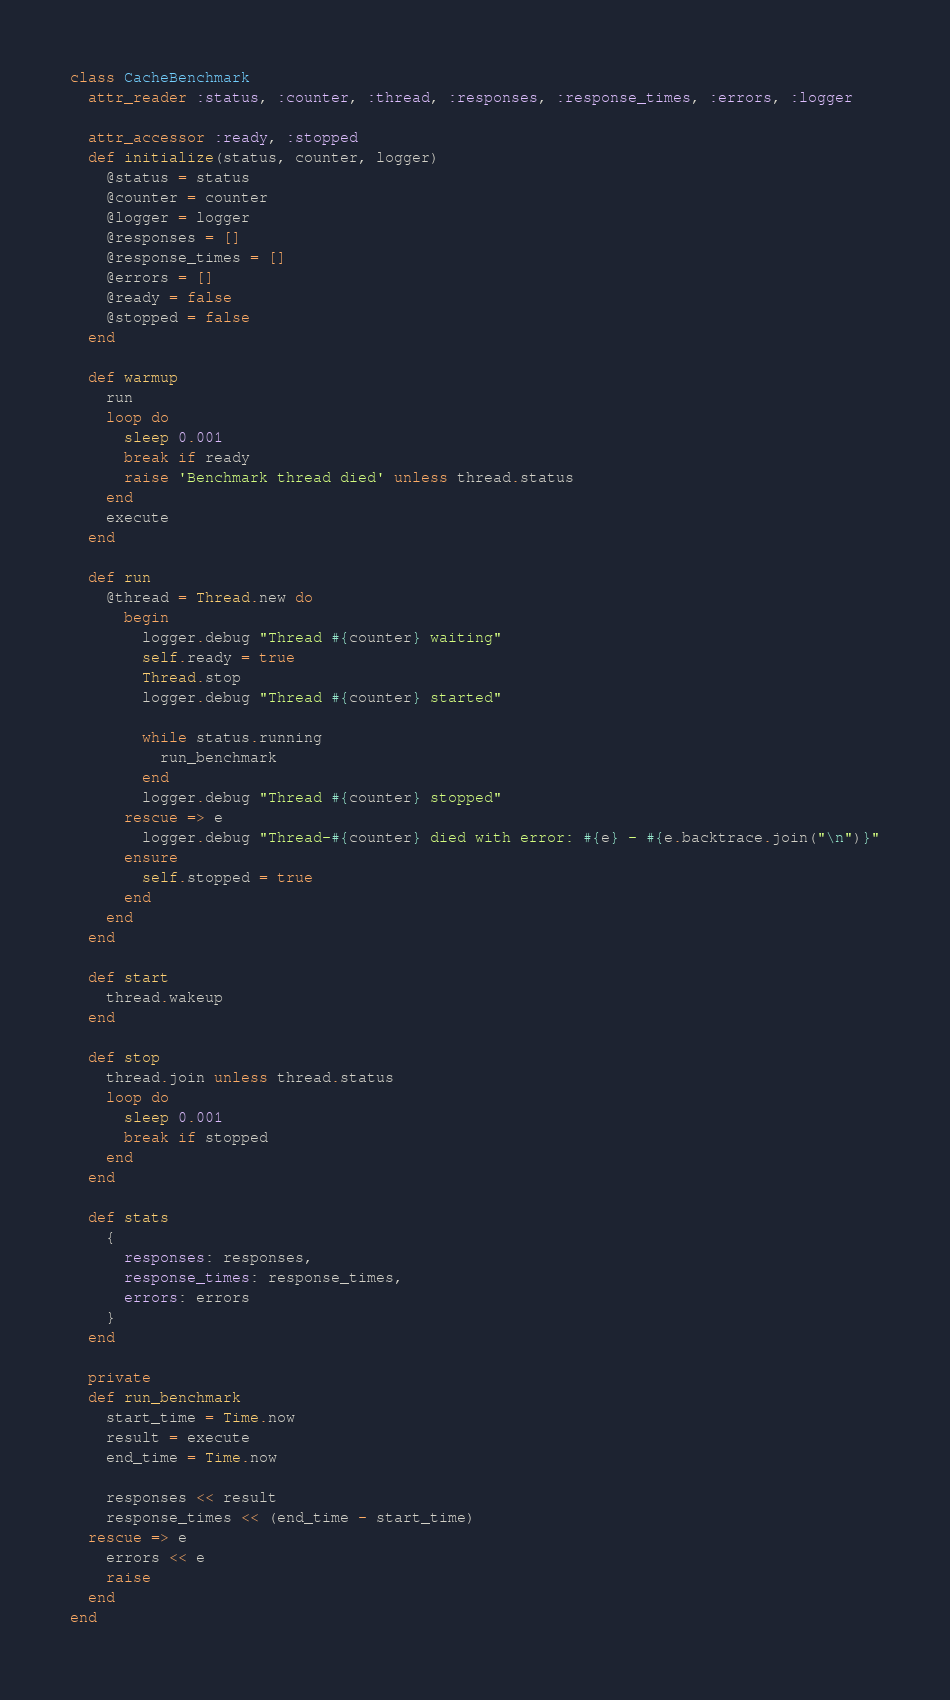Convert code to text. <code><loc_0><loc_0><loc_500><loc_500><_Ruby_>class CacheBenchmark
  attr_reader :status, :counter, :thread, :responses, :response_times, :errors, :logger
  
  attr_accessor :ready, :stopped
  def initialize(status, counter, logger)
    @status = status
    @counter = counter
    @logger = logger
    @responses = []
    @response_times = []
    @errors = []
    @ready = false
    @stopped = false
  end

  def warmup
    run
    loop do
      sleep 0.001
      break if ready
      raise 'Benchmark thread died' unless thread.status
    end
    execute
  end

  def run
    @thread = Thread.new do
      begin
        logger.debug "Thread #{counter} waiting"
        self.ready = true
        Thread.stop
        logger.debug "Thread #{counter} started"

        while status.running
          run_benchmark
        end
        logger.debug "Thread #{counter} stopped"
      rescue => e
        logger.debug "Thread-#{counter} died with error: #{e} - #{e.backtrace.join("\n")}"
      ensure
        self.stopped = true  
      end 
    end
  end

  def start
    thread.wakeup
  end

  def stop
    thread.join unless thread.status
    loop do
      sleep 0.001
      break if stopped
    end
  end

  def stats
    {
      responses: responses,
      response_times: response_times,
      errors: errors
    }
  end

  private
  def run_benchmark
    start_time = Time.now          
    result = execute
    end_time = Time.now

    responses << result 
    response_times << (end_time - start_time)
  rescue => e    
    errors << e
    raise
  end
end</code> 